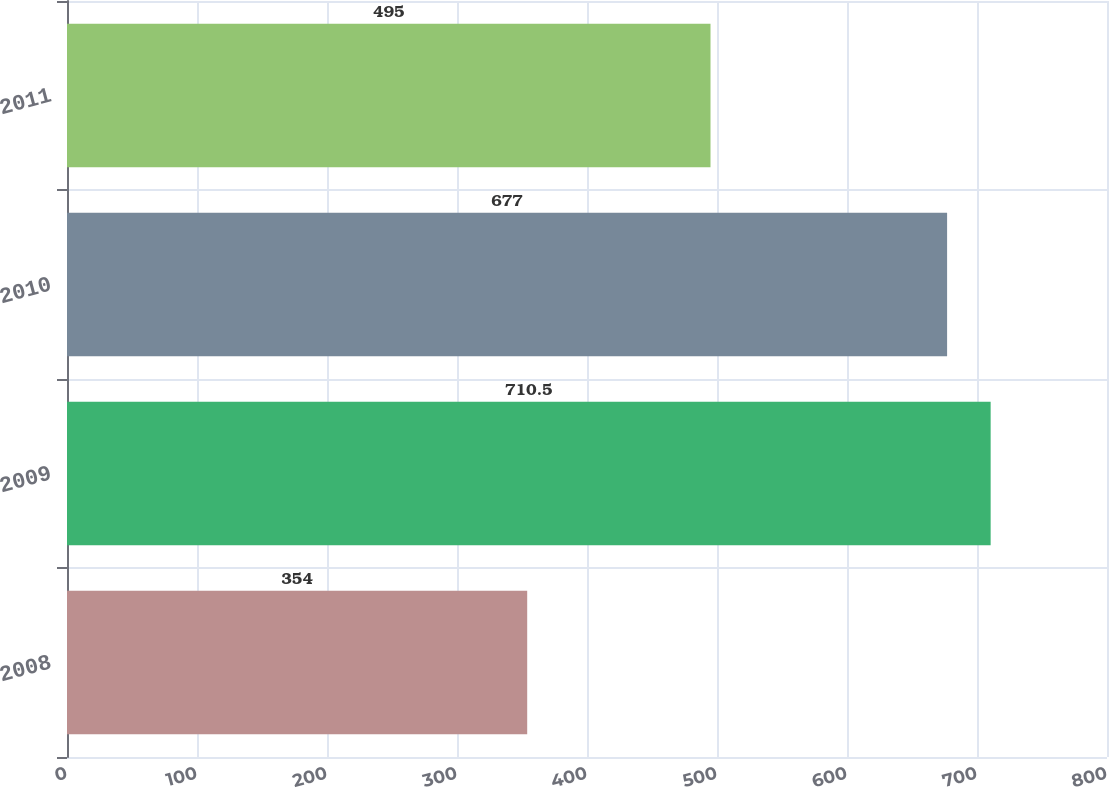Convert chart. <chart><loc_0><loc_0><loc_500><loc_500><bar_chart><fcel>2008<fcel>2009<fcel>2010<fcel>2011<nl><fcel>354<fcel>710.5<fcel>677<fcel>495<nl></chart> 